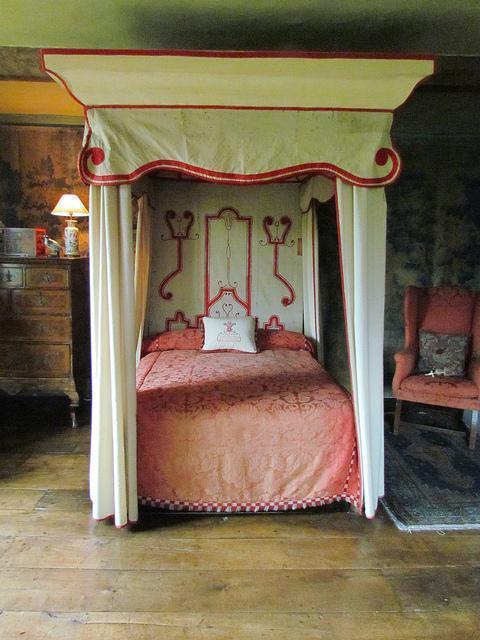How many pillows are on the bed?
Give a very brief answer. 3. How many birds in the water?
Give a very brief answer. 0. 